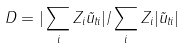Convert formula to latex. <formula><loc_0><loc_0><loc_500><loc_500>D = | \sum _ { i } Z _ { i } \vec { u } _ { t i } | / \sum _ { i } Z _ { i } | \vec { u } _ { t i } |</formula> 